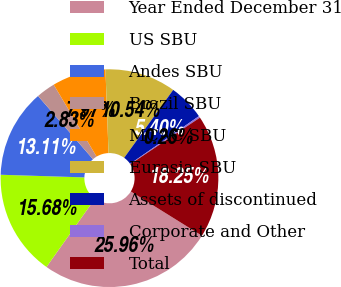Convert chart to OTSL. <chart><loc_0><loc_0><loc_500><loc_500><pie_chart><fcel>Year Ended December 31<fcel>US SBU<fcel>Andes SBU<fcel>Brazil SBU<fcel>MCAC SBU<fcel>Eurasia SBU<fcel>Assets of discontinued<fcel>Corporate and Other<fcel>Total<nl><fcel>25.96%<fcel>15.68%<fcel>13.11%<fcel>2.83%<fcel>7.97%<fcel>10.54%<fcel>5.4%<fcel>0.26%<fcel>18.25%<nl></chart> 